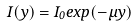<formula> <loc_0><loc_0><loc_500><loc_500>I ( y ) = I _ { 0 } e x p ( - \mu y )</formula> 